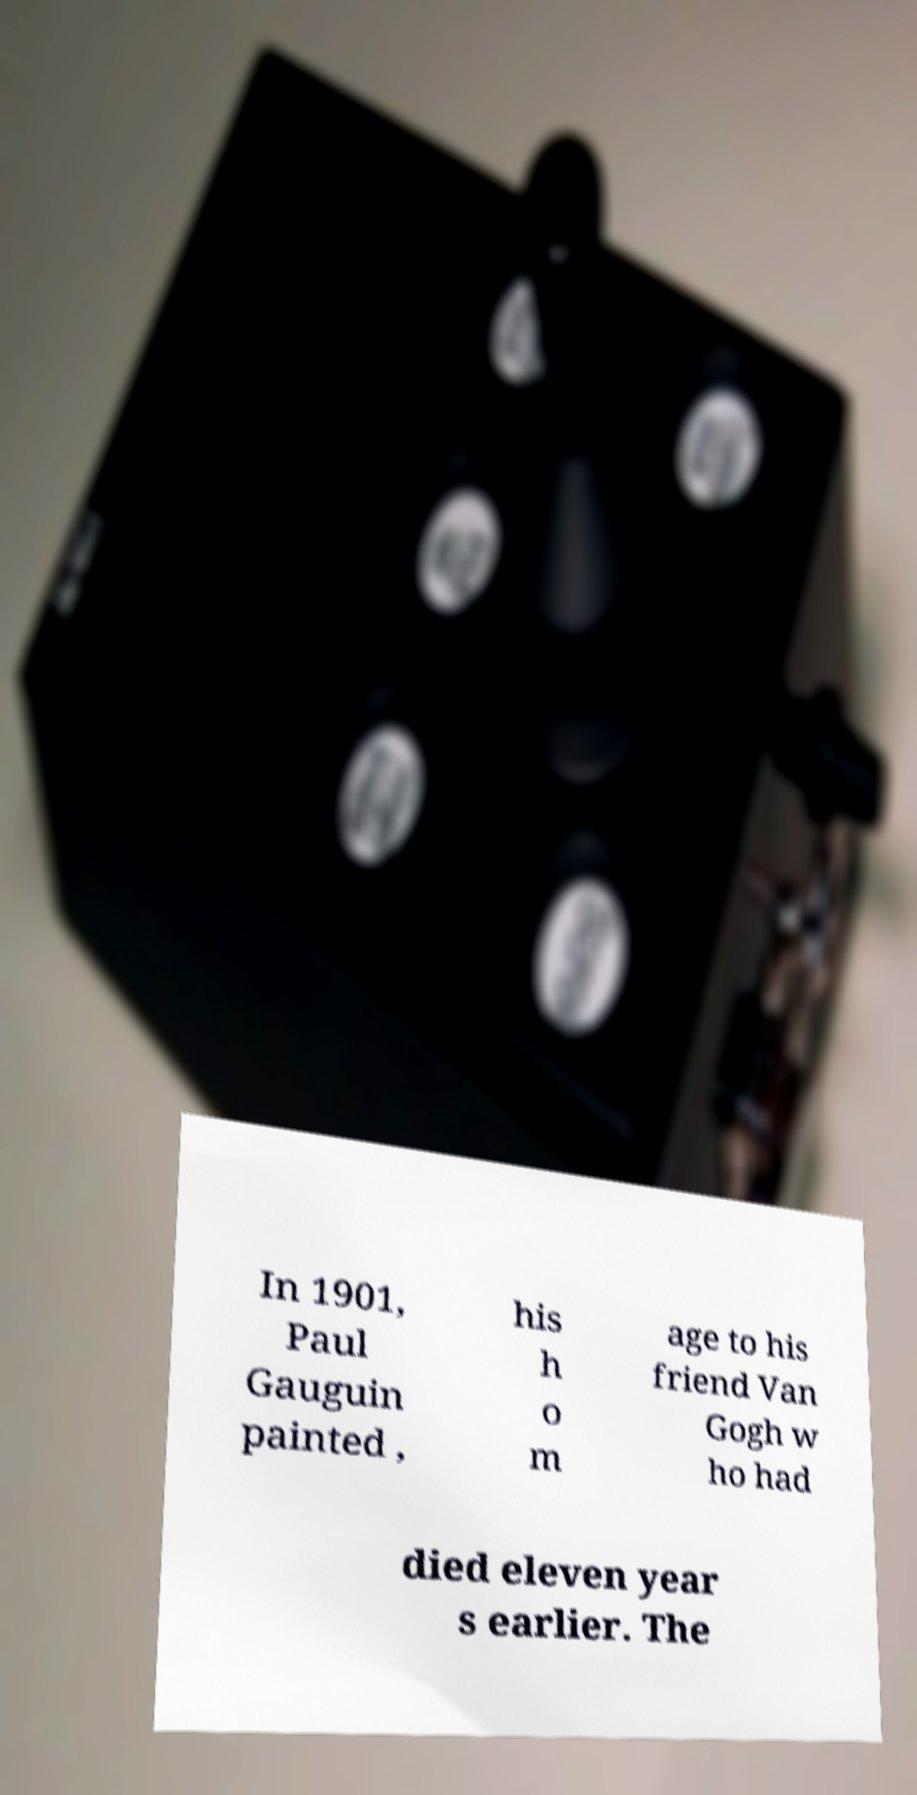Can you read and provide the text displayed in the image?This photo seems to have some interesting text. Can you extract and type it out for me? In 1901, Paul Gauguin painted , his h o m age to his friend Van Gogh w ho had died eleven year s earlier. The 